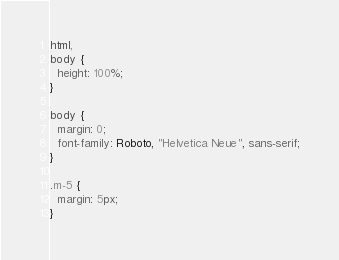<code> <loc_0><loc_0><loc_500><loc_500><_CSS_>html,
body {
  height: 100%;
}

body {
  margin: 0;
  font-family: Roboto, "Helvetica Neue", sans-serif;
}

.m-5 {
  margin: 5px;
}
</code> 